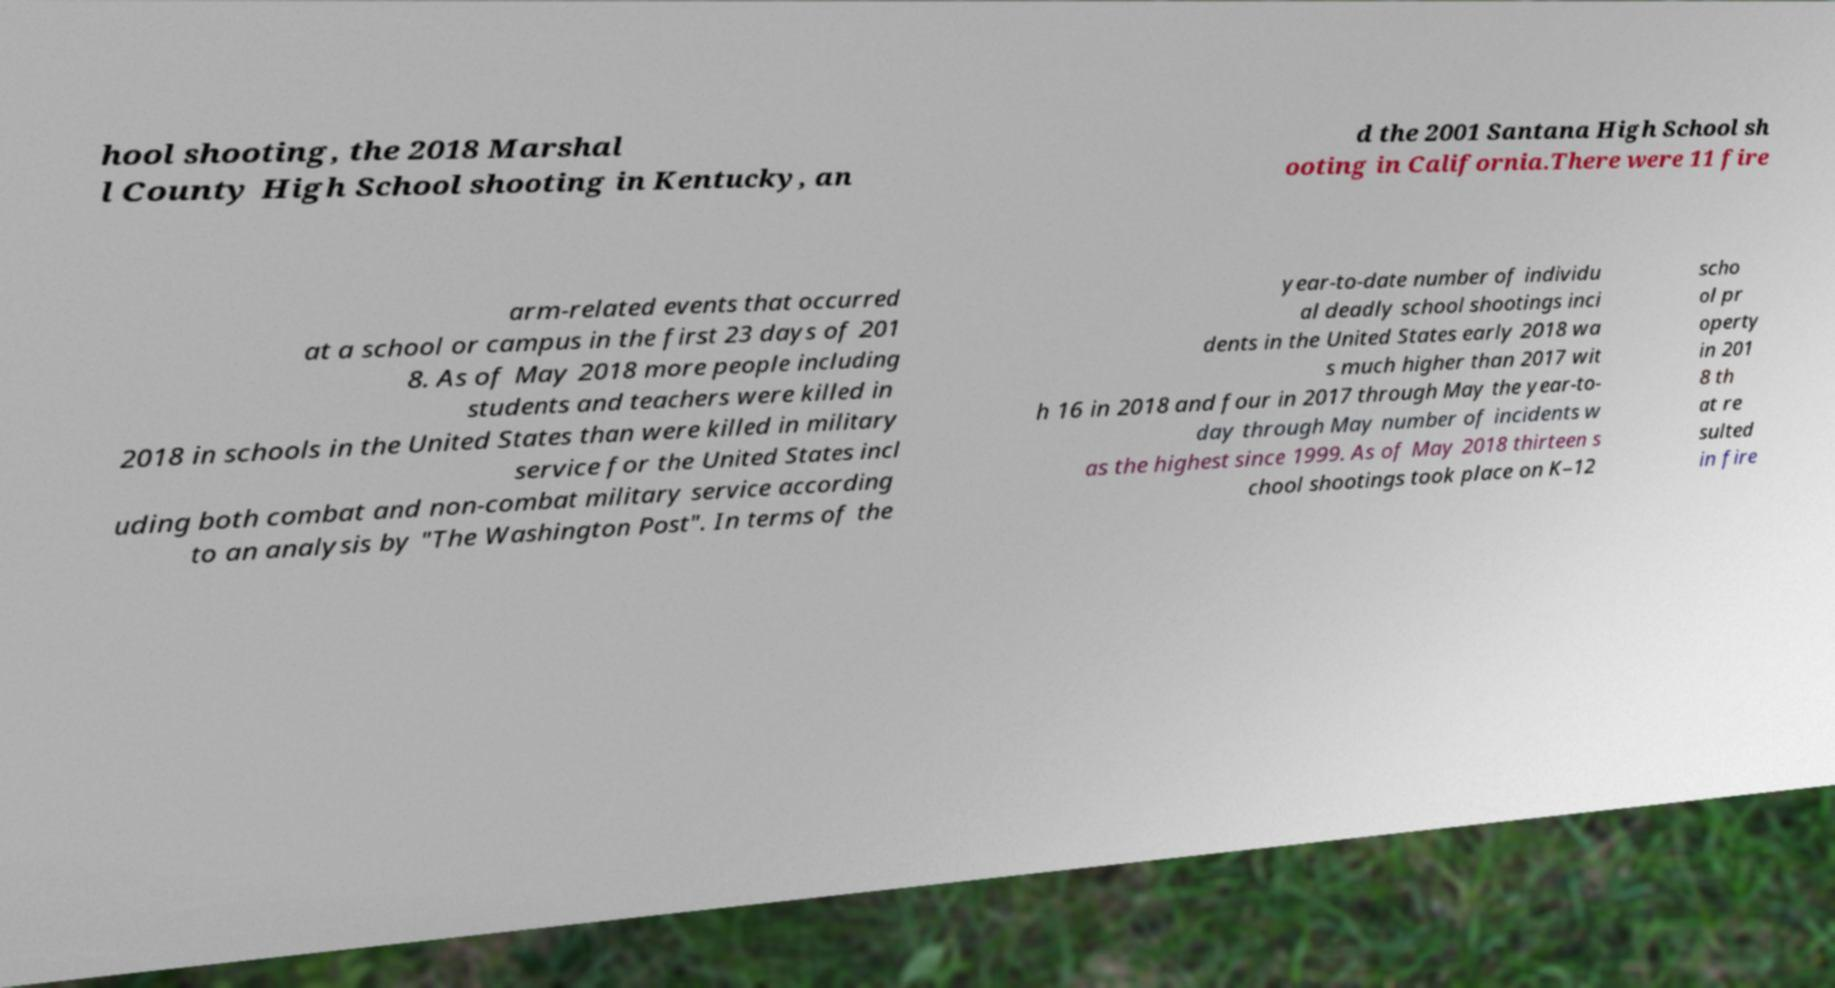Please identify and transcribe the text found in this image. hool shooting, the 2018 Marshal l County High School shooting in Kentucky, an d the 2001 Santana High School sh ooting in California.There were 11 fire arm-related events that occurred at a school or campus in the first 23 days of 201 8. As of May 2018 more people including students and teachers were killed in 2018 in schools in the United States than were killed in military service for the United States incl uding both combat and non-combat military service according to an analysis by "The Washington Post". In terms of the year-to-date number of individu al deadly school shootings inci dents in the United States early 2018 wa s much higher than 2017 wit h 16 in 2018 and four in 2017 through May the year-to- day through May number of incidents w as the highest since 1999. As of May 2018 thirteen s chool shootings took place on K–12 scho ol pr operty in 201 8 th at re sulted in fire 